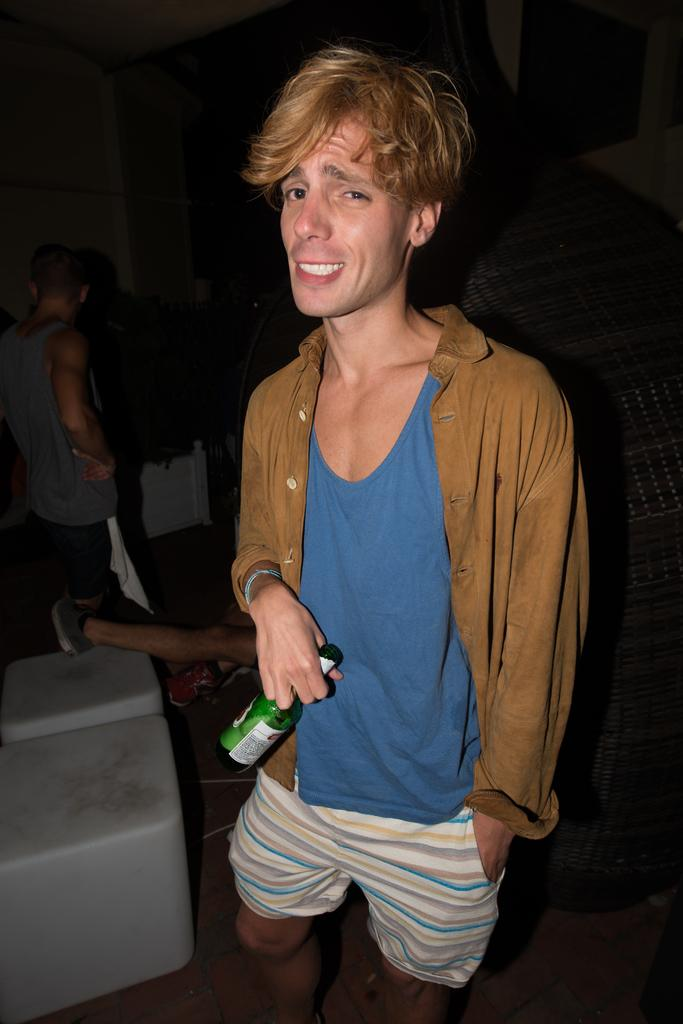How many people are in the image? There are persons standing in the image. What is one person holding in the image? There is a person holding a bottle in the image. What type of surface is visible in the image? There is a floor visible in the image. What type of furniture is present in the image? There are chairs in the image. What type of quartz can be seen on the person's nerve in the image? There is no quartz or mention of a nerve in the image; it features persons standing and a person holding a bottle. 